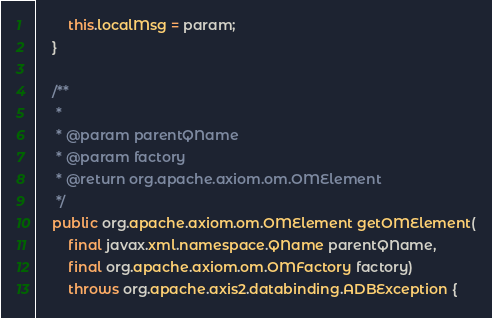<code> <loc_0><loc_0><loc_500><loc_500><_Java_>
        this.localMsg = param;
    }

    /**
     *
     * @param parentQName
     * @param factory
     * @return org.apache.axiom.om.OMElement
     */
    public org.apache.axiom.om.OMElement getOMElement(
        final javax.xml.namespace.QName parentQName,
        final org.apache.axiom.om.OMFactory factory)
        throws org.apache.axis2.databinding.ADBException {</code> 